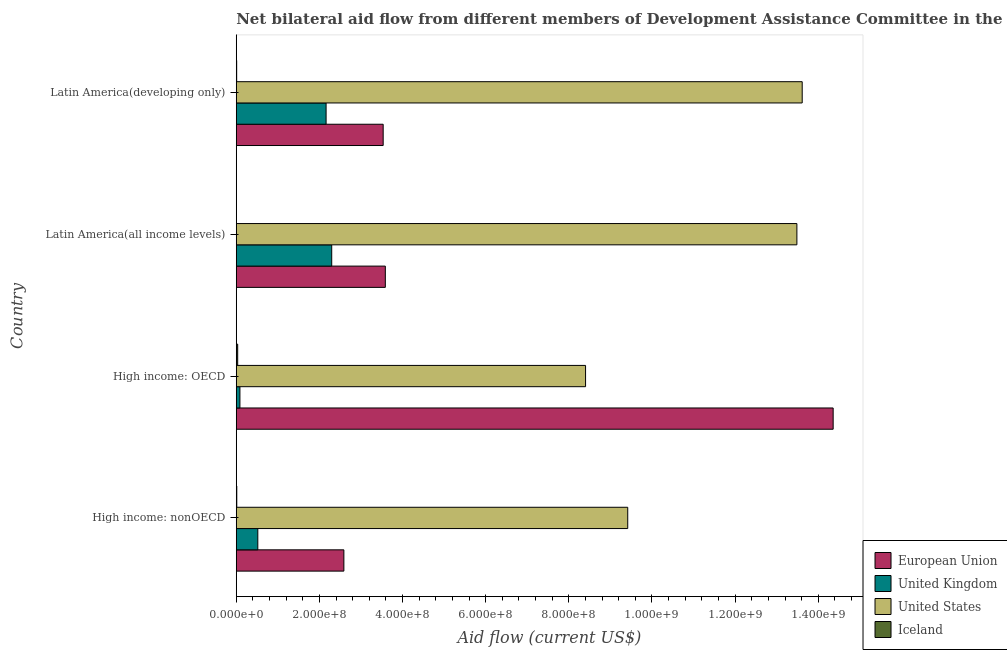How many different coloured bars are there?
Your answer should be very brief. 4. How many groups of bars are there?
Make the answer very short. 4. How many bars are there on the 4th tick from the top?
Your response must be concise. 4. How many bars are there on the 1st tick from the bottom?
Your answer should be compact. 4. What is the label of the 4th group of bars from the top?
Offer a terse response. High income: nonOECD. What is the amount of aid given by us in High income: OECD?
Your answer should be very brief. 8.40e+08. Across all countries, what is the maximum amount of aid given by uk?
Keep it short and to the point. 2.30e+08. Across all countries, what is the minimum amount of aid given by eu?
Your answer should be very brief. 2.59e+08. In which country was the amount of aid given by us maximum?
Your answer should be very brief. Latin America(developing only). In which country was the amount of aid given by uk minimum?
Offer a very short reply. High income: OECD. What is the total amount of aid given by eu in the graph?
Keep it short and to the point. 2.41e+09. What is the difference between the amount of aid given by iceland in High income: OECD and that in Latin America(all income levels)?
Ensure brevity in your answer.  3.23e+06. What is the difference between the amount of aid given by us in High income: nonOECD and the amount of aid given by uk in Latin America(all income levels)?
Offer a terse response. 7.12e+08. What is the average amount of aid given by eu per country?
Your response must be concise. 6.02e+08. What is the difference between the amount of aid given by eu and amount of aid given by uk in High income: nonOECD?
Offer a terse response. 2.07e+08. In how many countries, is the amount of aid given by iceland greater than 760000000 US$?
Provide a succinct answer. 0. Is the amount of aid given by eu in High income: OECD less than that in High income: nonOECD?
Provide a short and direct response. No. Is the difference between the amount of aid given by uk in High income: OECD and Latin America(all income levels) greater than the difference between the amount of aid given by eu in High income: OECD and Latin America(all income levels)?
Keep it short and to the point. No. What is the difference between the highest and the second highest amount of aid given by us?
Your response must be concise. 1.28e+07. What is the difference between the highest and the lowest amount of aid given by iceland?
Your answer should be very brief. 3.23e+06. What does the 3rd bar from the bottom in High income: OECD represents?
Your response must be concise. United States. How many bars are there?
Provide a short and direct response. 16. How many countries are there in the graph?
Provide a short and direct response. 4. What is the difference between two consecutive major ticks on the X-axis?
Make the answer very short. 2.00e+08. Are the values on the major ticks of X-axis written in scientific E-notation?
Ensure brevity in your answer.  Yes. Where does the legend appear in the graph?
Your response must be concise. Bottom right. How many legend labels are there?
Your response must be concise. 4. What is the title of the graph?
Provide a succinct answer. Net bilateral aid flow from different members of Development Assistance Committee in the year 2000. What is the label or title of the X-axis?
Offer a very short reply. Aid flow (current US$). What is the Aid flow (current US$) of European Union in High income: nonOECD?
Ensure brevity in your answer.  2.59e+08. What is the Aid flow (current US$) of United Kingdom in High income: nonOECD?
Offer a very short reply. 5.18e+07. What is the Aid flow (current US$) of United States in High income: nonOECD?
Provide a short and direct response. 9.42e+08. What is the Aid flow (current US$) of Iceland in High income: nonOECD?
Provide a short and direct response. 1.26e+06. What is the Aid flow (current US$) of European Union in High income: OECD?
Offer a terse response. 1.44e+09. What is the Aid flow (current US$) in United Kingdom in High income: OECD?
Provide a succinct answer. 8.84e+06. What is the Aid flow (current US$) in United States in High income: OECD?
Your answer should be very brief. 8.40e+08. What is the Aid flow (current US$) of Iceland in High income: OECD?
Your response must be concise. 3.44e+06. What is the Aid flow (current US$) in European Union in Latin America(all income levels)?
Provide a short and direct response. 3.59e+08. What is the Aid flow (current US$) of United Kingdom in Latin America(all income levels)?
Give a very brief answer. 2.30e+08. What is the Aid flow (current US$) in United States in Latin America(all income levels)?
Provide a short and direct response. 1.35e+09. What is the Aid flow (current US$) of European Union in Latin America(developing only)?
Offer a terse response. 3.53e+08. What is the Aid flow (current US$) of United Kingdom in Latin America(developing only)?
Your response must be concise. 2.16e+08. What is the Aid flow (current US$) of United States in Latin America(developing only)?
Your answer should be very brief. 1.36e+09. What is the Aid flow (current US$) of Iceland in Latin America(developing only)?
Offer a very short reply. 1.02e+06. Across all countries, what is the maximum Aid flow (current US$) of European Union?
Your response must be concise. 1.44e+09. Across all countries, what is the maximum Aid flow (current US$) of United Kingdom?
Offer a terse response. 2.30e+08. Across all countries, what is the maximum Aid flow (current US$) of United States?
Ensure brevity in your answer.  1.36e+09. Across all countries, what is the maximum Aid flow (current US$) of Iceland?
Your response must be concise. 3.44e+06. Across all countries, what is the minimum Aid flow (current US$) in European Union?
Offer a very short reply. 2.59e+08. Across all countries, what is the minimum Aid flow (current US$) in United Kingdom?
Keep it short and to the point. 8.84e+06. Across all countries, what is the minimum Aid flow (current US$) of United States?
Offer a terse response. 8.40e+08. What is the total Aid flow (current US$) in European Union in the graph?
Keep it short and to the point. 2.41e+09. What is the total Aid flow (current US$) in United Kingdom in the graph?
Your response must be concise. 5.06e+08. What is the total Aid flow (current US$) of United States in the graph?
Your answer should be very brief. 4.49e+09. What is the total Aid flow (current US$) in Iceland in the graph?
Offer a terse response. 5.93e+06. What is the difference between the Aid flow (current US$) of European Union in High income: nonOECD and that in High income: OECD?
Ensure brevity in your answer.  -1.18e+09. What is the difference between the Aid flow (current US$) in United Kingdom in High income: nonOECD and that in High income: OECD?
Offer a terse response. 4.30e+07. What is the difference between the Aid flow (current US$) in United States in High income: nonOECD and that in High income: OECD?
Ensure brevity in your answer.  1.01e+08. What is the difference between the Aid flow (current US$) in Iceland in High income: nonOECD and that in High income: OECD?
Your answer should be very brief. -2.18e+06. What is the difference between the Aid flow (current US$) in European Union in High income: nonOECD and that in Latin America(all income levels)?
Offer a terse response. -9.97e+07. What is the difference between the Aid flow (current US$) in United Kingdom in High income: nonOECD and that in Latin America(all income levels)?
Make the answer very short. -1.78e+08. What is the difference between the Aid flow (current US$) of United States in High income: nonOECD and that in Latin America(all income levels)?
Offer a very short reply. -4.07e+08. What is the difference between the Aid flow (current US$) of Iceland in High income: nonOECD and that in Latin America(all income levels)?
Your answer should be very brief. 1.05e+06. What is the difference between the Aid flow (current US$) of European Union in High income: nonOECD and that in Latin America(developing only)?
Offer a very short reply. -9.45e+07. What is the difference between the Aid flow (current US$) of United Kingdom in High income: nonOECD and that in Latin America(developing only)?
Offer a very short reply. -1.64e+08. What is the difference between the Aid flow (current US$) of United States in High income: nonOECD and that in Latin America(developing only)?
Your response must be concise. -4.20e+08. What is the difference between the Aid flow (current US$) in European Union in High income: OECD and that in Latin America(all income levels)?
Provide a short and direct response. 1.08e+09. What is the difference between the Aid flow (current US$) in United Kingdom in High income: OECD and that in Latin America(all income levels)?
Your answer should be very brief. -2.21e+08. What is the difference between the Aid flow (current US$) in United States in High income: OECD and that in Latin America(all income levels)?
Your response must be concise. -5.08e+08. What is the difference between the Aid flow (current US$) of Iceland in High income: OECD and that in Latin America(all income levels)?
Your response must be concise. 3.23e+06. What is the difference between the Aid flow (current US$) of European Union in High income: OECD and that in Latin America(developing only)?
Provide a short and direct response. 1.08e+09. What is the difference between the Aid flow (current US$) in United Kingdom in High income: OECD and that in Latin America(developing only)?
Offer a terse response. -2.07e+08. What is the difference between the Aid flow (current US$) of United States in High income: OECD and that in Latin America(developing only)?
Ensure brevity in your answer.  -5.21e+08. What is the difference between the Aid flow (current US$) in Iceland in High income: OECD and that in Latin America(developing only)?
Provide a succinct answer. 2.42e+06. What is the difference between the Aid flow (current US$) in European Union in Latin America(all income levels) and that in Latin America(developing only)?
Offer a terse response. 5.20e+06. What is the difference between the Aid flow (current US$) of United Kingdom in Latin America(all income levels) and that in Latin America(developing only)?
Provide a short and direct response. 1.35e+07. What is the difference between the Aid flow (current US$) in United States in Latin America(all income levels) and that in Latin America(developing only)?
Provide a short and direct response. -1.28e+07. What is the difference between the Aid flow (current US$) in Iceland in Latin America(all income levels) and that in Latin America(developing only)?
Offer a terse response. -8.10e+05. What is the difference between the Aid flow (current US$) in European Union in High income: nonOECD and the Aid flow (current US$) in United Kingdom in High income: OECD?
Your answer should be compact. 2.50e+08. What is the difference between the Aid flow (current US$) of European Union in High income: nonOECD and the Aid flow (current US$) of United States in High income: OECD?
Ensure brevity in your answer.  -5.81e+08. What is the difference between the Aid flow (current US$) in European Union in High income: nonOECD and the Aid flow (current US$) in Iceland in High income: OECD?
Your answer should be compact. 2.55e+08. What is the difference between the Aid flow (current US$) in United Kingdom in High income: nonOECD and the Aid flow (current US$) in United States in High income: OECD?
Give a very brief answer. -7.88e+08. What is the difference between the Aid flow (current US$) in United Kingdom in High income: nonOECD and the Aid flow (current US$) in Iceland in High income: OECD?
Make the answer very short. 4.84e+07. What is the difference between the Aid flow (current US$) of United States in High income: nonOECD and the Aid flow (current US$) of Iceland in High income: OECD?
Offer a very short reply. 9.38e+08. What is the difference between the Aid flow (current US$) in European Union in High income: nonOECD and the Aid flow (current US$) in United Kingdom in Latin America(all income levels)?
Give a very brief answer. 2.93e+07. What is the difference between the Aid flow (current US$) of European Union in High income: nonOECD and the Aid flow (current US$) of United States in Latin America(all income levels)?
Ensure brevity in your answer.  -1.09e+09. What is the difference between the Aid flow (current US$) of European Union in High income: nonOECD and the Aid flow (current US$) of Iceland in Latin America(all income levels)?
Provide a succinct answer. 2.59e+08. What is the difference between the Aid flow (current US$) in United Kingdom in High income: nonOECD and the Aid flow (current US$) in United States in Latin America(all income levels)?
Your answer should be very brief. -1.30e+09. What is the difference between the Aid flow (current US$) in United Kingdom in High income: nonOECD and the Aid flow (current US$) in Iceland in Latin America(all income levels)?
Keep it short and to the point. 5.16e+07. What is the difference between the Aid flow (current US$) of United States in High income: nonOECD and the Aid flow (current US$) of Iceland in Latin America(all income levels)?
Your response must be concise. 9.41e+08. What is the difference between the Aid flow (current US$) of European Union in High income: nonOECD and the Aid flow (current US$) of United Kingdom in Latin America(developing only)?
Provide a succinct answer. 4.28e+07. What is the difference between the Aid flow (current US$) in European Union in High income: nonOECD and the Aid flow (current US$) in United States in Latin America(developing only)?
Provide a short and direct response. -1.10e+09. What is the difference between the Aid flow (current US$) of European Union in High income: nonOECD and the Aid flow (current US$) of Iceland in Latin America(developing only)?
Provide a succinct answer. 2.58e+08. What is the difference between the Aid flow (current US$) in United Kingdom in High income: nonOECD and the Aid flow (current US$) in United States in Latin America(developing only)?
Make the answer very short. -1.31e+09. What is the difference between the Aid flow (current US$) in United Kingdom in High income: nonOECD and the Aid flow (current US$) in Iceland in Latin America(developing only)?
Your answer should be very brief. 5.08e+07. What is the difference between the Aid flow (current US$) of United States in High income: nonOECD and the Aid flow (current US$) of Iceland in Latin America(developing only)?
Give a very brief answer. 9.41e+08. What is the difference between the Aid flow (current US$) in European Union in High income: OECD and the Aid flow (current US$) in United Kingdom in Latin America(all income levels)?
Ensure brevity in your answer.  1.21e+09. What is the difference between the Aid flow (current US$) of European Union in High income: OECD and the Aid flow (current US$) of United States in Latin America(all income levels)?
Provide a succinct answer. 8.73e+07. What is the difference between the Aid flow (current US$) in European Union in High income: OECD and the Aid flow (current US$) in Iceland in Latin America(all income levels)?
Give a very brief answer. 1.44e+09. What is the difference between the Aid flow (current US$) of United Kingdom in High income: OECD and the Aid flow (current US$) of United States in Latin America(all income levels)?
Your response must be concise. -1.34e+09. What is the difference between the Aid flow (current US$) of United Kingdom in High income: OECD and the Aid flow (current US$) of Iceland in Latin America(all income levels)?
Provide a succinct answer. 8.63e+06. What is the difference between the Aid flow (current US$) in United States in High income: OECD and the Aid flow (current US$) in Iceland in Latin America(all income levels)?
Offer a very short reply. 8.40e+08. What is the difference between the Aid flow (current US$) of European Union in High income: OECD and the Aid flow (current US$) of United Kingdom in Latin America(developing only)?
Keep it short and to the point. 1.22e+09. What is the difference between the Aid flow (current US$) of European Union in High income: OECD and the Aid flow (current US$) of United States in Latin America(developing only)?
Make the answer very short. 7.44e+07. What is the difference between the Aid flow (current US$) of European Union in High income: OECD and the Aid flow (current US$) of Iceland in Latin America(developing only)?
Your answer should be compact. 1.43e+09. What is the difference between the Aid flow (current US$) of United Kingdom in High income: OECD and the Aid flow (current US$) of United States in Latin America(developing only)?
Provide a short and direct response. -1.35e+09. What is the difference between the Aid flow (current US$) of United Kingdom in High income: OECD and the Aid flow (current US$) of Iceland in Latin America(developing only)?
Provide a short and direct response. 7.82e+06. What is the difference between the Aid flow (current US$) in United States in High income: OECD and the Aid flow (current US$) in Iceland in Latin America(developing only)?
Offer a terse response. 8.39e+08. What is the difference between the Aid flow (current US$) of European Union in Latin America(all income levels) and the Aid flow (current US$) of United Kingdom in Latin America(developing only)?
Give a very brief answer. 1.42e+08. What is the difference between the Aid flow (current US$) of European Union in Latin America(all income levels) and the Aid flow (current US$) of United States in Latin America(developing only)?
Ensure brevity in your answer.  -1.00e+09. What is the difference between the Aid flow (current US$) in European Union in Latin America(all income levels) and the Aid flow (current US$) in Iceland in Latin America(developing only)?
Offer a very short reply. 3.58e+08. What is the difference between the Aid flow (current US$) of United Kingdom in Latin America(all income levels) and the Aid flow (current US$) of United States in Latin America(developing only)?
Your response must be concise. -1.13e+09. What is the difference between the Aid flow (current US$) of United Kingdom in Latin America(all income levels) and the Aid flow (current US$) of Iceland in Latin America(developing only)?
Your response must be concise. 2.29e+08. What is the difference between the Aid flow (current US$) in United States in Latin America(all income levels) and the Aid flow (current US$) in Iceland in Latin America(developing only)?
Your response must be concise. 1.35e+09. What is the average Aid flow (current US$) in European Union per country?
Your response must be concise. 6.02e+08. What is the average Aid flow (current US$) of United Kingdom per country?
Offer a very short reply. 1.27e+08. What is the average Aid flow (current US$) of United States per country?
Make the answer very short. 1.12e+09. What is the average Aid flow (current US$) in Iceland per country?
Your answer should be very brief. 1.48e+06. What is the difference between the Aid flow (current US$) of European Union and Aid flow (current US$) of United Kingdom in High income: nonOECD?
Give a very brief answer. 2.07e+08. What is the difference between the Aid flow (current US$) in European Union and Aid flow (current US$) in United States in High income: nonOECD?
Ensure brevity in your answer.  -6.83e+08. What is the difference between the Aid flow (current US$) in European Union and Aid flow (current US$) in Iceland in High income: nonOECD?
Keep it short and to the point. 2.58e+08. What is the difference between the Aid flow (current US$) in United Kingdom and Aid flow (current US$) in United States in High income: nonOECD?
Your answer should be very brief. -8.90e+08. What is the difference between the Aid flow (current US$) of United Kingdom and Aid flow (current US$) of Iceland in High income: nonOECD?
Make the answer very short. 5.06e+07. What is the difference between the Aid flow (current US$) in United States and Aid flow (current US$) in Iceland in High income: nonOECD?
Offer a very short reply. 9.40e+08. What is the difference between the Aid flow (current US$) in European Union and Aid flow (current US$) in United Kingdom in High income: OECD?
Your answer should be compact. 1.43e+09. What is the difference between the Aid flow (current US$) in European Union and Aid flow (current US$) in United States in High income: OECD?
Offer a very short reply. 5.96e+08. What is the difference between the Aid flow (current US$) of European Union and Aid flow (current US$) of Iceland in High income: OECD?
Your answer should be compact. 1.43e+09. What is the difference between the Aid flow (current US$) in United Kingdom and Aid flow (current US$) in United States in High income: OECD?
Your answer should be very brief. -8.31e+08. What is the difference between the Aid flow (current US$) in United Kingdom and Aid flow (current US$) in Iceland in High income: OECD?
Give a very brief answer. 5.40e+06. What is the difference between the Aid flow (current US$) in United States and Aid flow (current US$) in Iceland in High income: OECD?
Your answer should be compact. 8.37e+08. What is the difference between the Aid flow (current US$) in European Union and Aid flow (current US$) in United Kingdom in Latin America(all income levels)?
Give a very brief answer. 1.29e+08. What is the difference between the Aid flow (current US$) in European Union and Aid flow (current US$) in United States in Latin America(all income levels)?
Your response must be concise. -9.90e+08. What is the difference between the Aid flow (current US$) of European Union and Aid flow (current US$) of Iceland in Latin America(all income levels)?
Your answer should be compact. 3.58e+08. What is the difference between the Aid flow (current US$) in United Kingdom and Aid flow (current US$) in United States in Latin America(all income levels)?
Offer a terse response. -1.12e+09. What is the difference between the Aid flow (current US$) of United Kingdom and Aid flow (current US$) of Iceland in Latin America(all income levels)?
Offer a very short reply. 2.29e+08. What is the difference between the Aid flow (current US$) in United States and Aid flow (current US$) in Iceland in Latin America(all income levels)?
Your answer should be compact. 1.35e+09. What is the difference between the Aid flow (current US$) in European Union and Aid flow (current US$) in United Kingdom in Latin America(developing only)?
Your answer should be very brief. 1.37e+08. What is the difference between the Aid flow (current US$) in European Union and Aid flow (current US$) in United States in Latin America(developing only)?
Provide a short and direct response. -1.01e+09. What is the difference between the Aid flow (current US$) in European Union and Aid flow (current US$) in Iceland in Latin America(developing only)?
Your answer should be very brief. 3.52e+08. What is the difference between the Aid flow (current US$) of United Kingdom and Aid flow (current US$) of United States in Latin America(developing only)?
Keep it short and to the point. -1.15e+09. What is the difference between the Aid flow (current US$) of United Kingdom and Aid flow (current US$) of Iceland in Latin America(developing only)?
Provide a succinct answer. 2.15e+08. What is the difference between the Aid flow (current US$) in United States and Aid flow (current US$) in Iceland in Latin America(developing only)?
Your answer should be very brief. 1.36e+09. What is the ratio of the Aid flow (current US$) of European Union in High income: nonOECD to that in High income: OECD?
Provide a succinct answer. 0.18. What is the ratio of the Aid flow (current US$) in United Kingdom in High income: nonOECD to that in High income: OECD?
Your answer should be compact. 5.86. What is the ratio of the Aid flow (current US$) in United States in High income: nonOECD to that in High income: OECD?
Provide a succinct answer. 1.12. What is the ratio of the Aid flow (current US$) in Iceland in High income: nonOECD to that in High income: OECD?
Provide a succinct answer. 0.37. What is the ratio of the Aid flow (current US$) of European Union in High income: nonOECD to that in Latin America(all income levels)?
Provide a succinct answer. 0.72. What is the ratio of the Aid flow (current US$) in United Kingdom in High income: nonOECD to that in Latin America(all income levels)?
Provide a short and direct response. 0.23. What is the ratio of the Aid flow (current US$) of United States in High income: nonOECD to that in Latin America(all income levels)?
Your answer should be very brief. 0.7. What is the ratio of the Aid flow (current US$) in Iceland in High income: nonOECD to that in Latin America(all income levels)?
Keep it short and to the point. 6. What is the ratio of the Aid flow (current US$) in European Union in High income: nonOECD to that in Latin America(developing only)?
Your answer should be compact. 0.73. What is the ratio of the Aid flow (current US$) of United Kingdom in High income: nonOECD to that in Latin America(developing only)?
Give a very brief answer. 0.24. What is the ratio of the Aid flow (current US$) of United States in High income: nonOECD to that in Latin America(developing only)?
Keep it short and to the point. 0.69. What is the ratio of the Aid flow (current US$) in Iceland in High income: nonOECD to that in Latin America(developing only)?
Ensure brevity in your answer.  1.24. What is the ratio of the Aid flow (current US$) of European Union in High income: OECD to that in Latin America(all income levels)?
Your answer should be very brief. 4. What is the ratio of the Aid flow (current US$) of United Kingdom in High income: OECD to that in Latin America(all income levels)?
Give a very brief answer. 0.04. What is the ratio of the Aid flow (current US$) of United States in High income: OECD to that in Latin America(all income levels)?
Ensure brevity in your answer.  0.62. What is the ratio of the Aid flow (current US$) in Iceland in High income: OECD to that in Latin America(all income levels)?
Offer a very short reply. 16.38. What is the ratio of the Aid flow (current US$) of European Union in High income: OECD to that in Latin America(developing only)?
Offer a terse response. 4.06. What is the ratio of the Aid flow (current US$) in United Kingdom in High income: OECD to that in Latin America(developing only)?
Your response must be concise. 0.04. What is the ratio of the Aid flow (current US$) in United States in High income: OECD to that in Latin America(developing only)?
Ensure brevity in your answer.  0.62. What is the ratio of the Aid flow (current US$) of Iceland in High income: OECD to that in Latin America(developing only)?
Offer a very short reply. 3.37. What is the ratio of the Aid flow (current US$) of European Union in Latin America(all income levels) to that in Latin America(developing only)?
Ensure brevity in your answer.  1.01. What is the ratio of the Aid flow (current US$) in United Kingdom in Latin America(all income levels) to that in Latin America(developing only)?
Your answer should be compact. 1.06. What is the ratio of the Aid flow (current US$) of United States in Latin America(all income levels) to that in Latin America(developing only)?
Provide a succinct answer. 0.99. What is the ratio of the Aid flow (current US$) of Iceland in Latin America(all income levels) to that in Latin America(developing only)?
Offer a very short reply. 0.21. What is the difference between the highest and the second highest Aid flow (current US$) in European Union?
Provide a short and direct response. 1.08e+09. What is the difference between the highest and the second highest Aid flow (current US$) in United Kingdom?
Make the answer very short. 1.35e+07. What is the difference between the highest and the second highest Aid flow (current US$) in United States?
Give a very brief answer. 1.28e+07. What is the difference between the highest and the second highest Aid flow (current US$) in Iceland?
Make the answer very short. 2.18e+06. What is the difference between the highest and the lowest Aid flow (current US$) of European Union?
Your response must be concise. 1.18e+09. What is the difference between the highest and the lowest Aid flow (current US$) of United Kingdom?
Ensure brevity in your answer.  2.21e+08. What is the difference between the highest and the lowest Aid flow (current US$) of United States?
Your answer should be compact. 5.21e+08. What is the difference between the highest and the lowest Aid flow (current US$) of Iceland?
Make the answer very short. 3.23e+06. 